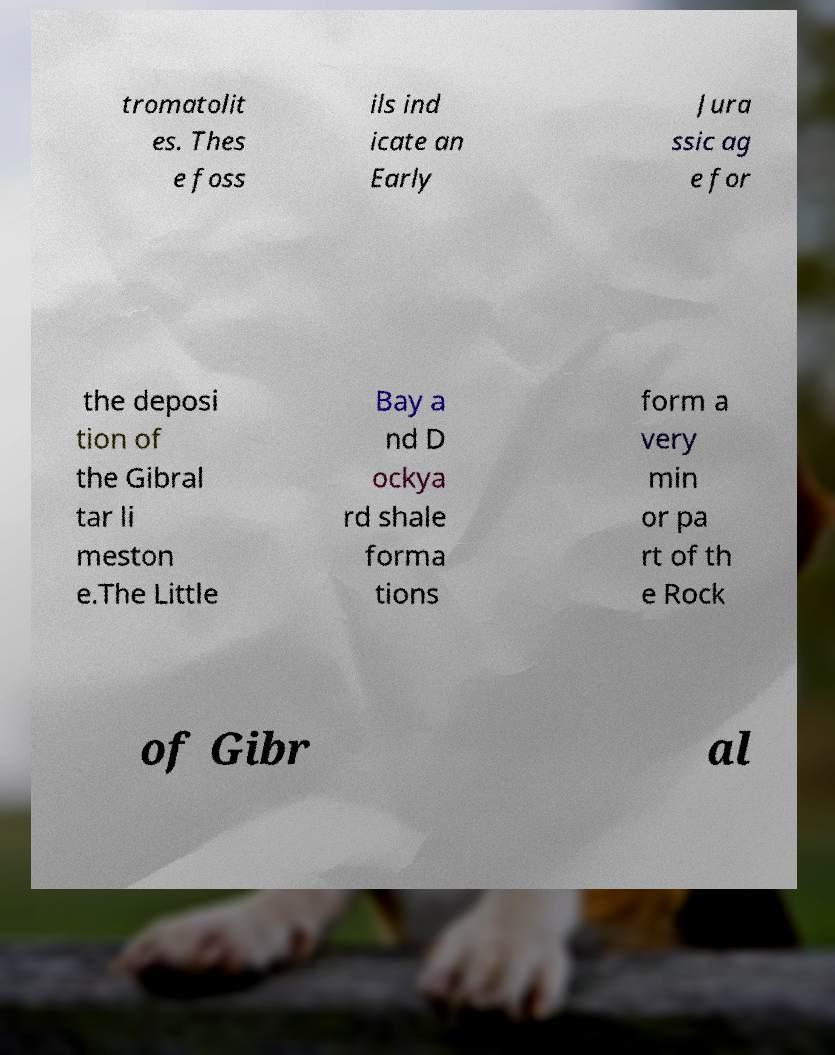There's text embedded in this image that I need extracted. Can you transcribe it verbatim? tromatolit es. Thes e foss ils ind icate an Early Jura ssic ag e for the deposi tion of the Gibral tar li meston e.The Little Bay a nd D ockya rd shale forma tions form a very min or pa rt of th e Rock of Gibr al 